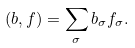<formula> <loc_0><loc_0><loc_500><loc_500>( b , f ) = \sum _ { \sigma } b _ { \sigma } f _ { \sigma } .</formula> 